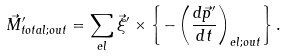<formula> <loc_0><loc_0><loc_500><loc_500>\vec { M } ^ { \prime } _ { t o t a l ; o u t } = \sum _ { e l } \vec { \xi } ^ { \prime } \times \left \{ - \left ( \frac { d \vec { p } ^ { \prime } } { d t } \right ) _ { e l ; o u t } \right \} .</formula> 